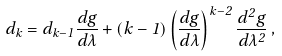<formula> <loc_0><loc_0><loc_500><loc_500>d _ { k } = d _ { k - 1 } \frac { d g } { d \lambda } + ( k - 1 ) \left ( \frac { d g } { d \lambda } \right ) ^ { k - 2 } \frac { d ^ { 2 } g } { d \lambda ^ { 2 } } \, ,</formula> 